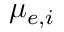Convert formula to latex. <formula><loc_0><loc_0><loc_500><loc_500>\mu _ { e , i }</formula> 